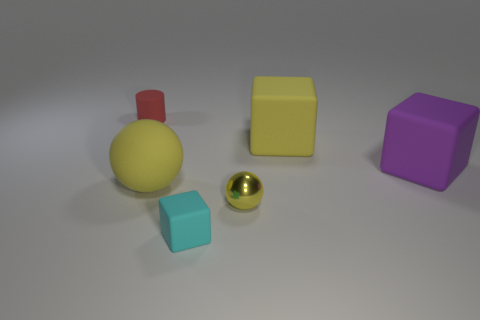Add 1 yellow matte cubes. How many objects exist? 7 Subtract all spheres. How many objects are left? 4 Add 4 yellow metal balls. How many yellow metal balls are left? 5 Add 2 small metallic balls. How many small metallic balls exist? 3 Subtract 0 green balls. How many objects are left? 6 Subtract all things. Subtract all big gray metal objects. How many objects are left? 0 